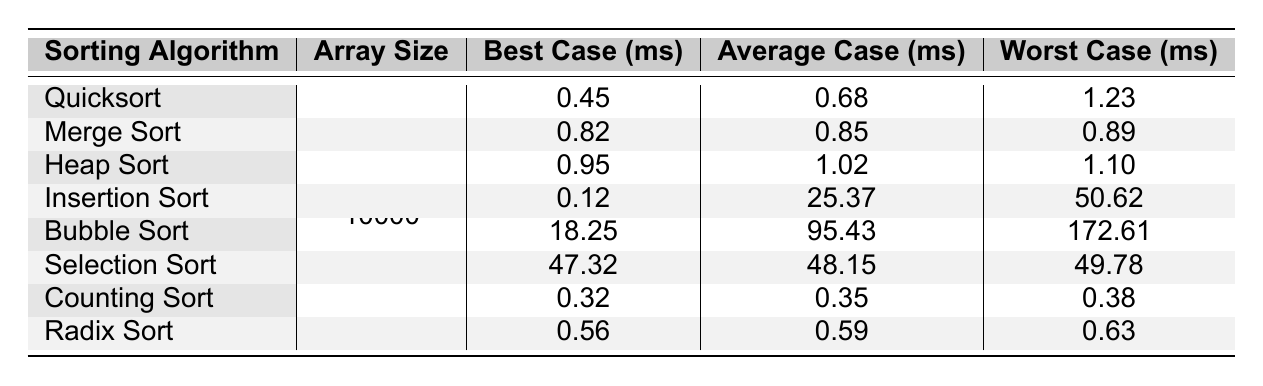What is the best case execution time for Quicksort? From the table, under the "Best Case (ms)" column for "Quicksort," the value is 0.45.
Answer: 0.45 ms Which sorting algorithm has the worst average case execution time? By looking at the "Average Case (ms)" column, "Insertion Sort" has the maximum value of 25.37 compared to others.
Answer: Insertion Sort What is the difference in the worst-case execution times between Bubble Sort and Counting Sort? The worst-case execution time for Bubble Sort is 172.61 ms and for Counting Sort is 0.38 ms. The difference is 172.61 - 0.38 = 172.23 ms.
Answer: 172.23 ms Which sorting algorithm has the minimum best case execution time? Reviewing the "Best Case (ms)" column reveals that "Counting Sort" has the minimum value of 0.32 ms.
Answer: Counting Sort Is the average case execution time for Merge Sort less than that for Radix Sort? The average case time for Merge Sort is 0.85 ms and for Radix Sort is 0.59 ms. Since 0.85 is greater than 0.59, the statement is False.
Answer: No What is the total of the best case execution times for Quicksort, Heap Sort, and Radix Sort? The best case times for these algorithms are 0.45 ms (Quicksort), 0.95 ms (Heap Sort), and 0.56 ms (Radix Sort). Summing these gives: 0.45 + 0.95 + 0.56 = 1.96 ms.
Answer: 1.96 ms Which algorithm had the highest worst-case execution time, and what was that time? In the "Worst Case (ms)" column, "Bubble Sort" has the highest value at 172.61 ms.
Answer: Bubble Sort, 172.61 ms Does any sorting algorithm have an average case execution time below 1 ms? Checking the "Average Case (ms)" column, all values are above 1 ms except for Counting Sort (0.35 ms). Thus, Yes, there is one.
Answer: Yes What is the median best case execution time of all the sorting algorithms listed? The best case times are: 0.12, 0.32, 0.45, 0.56, 0.82, 0.95, 18.25, 47.32. When sorted, the median is the average of the 4th and 5th values: (0.56 + 0.82) / 2 = 0.69.
Answer: 0.69 ms How does the worst case execution time of Insertion Sort compare to that of Selection Sort? The worst case for Insertion Sort is 50.62 ms, while for Selection Sort it is 49.78 ms. Insertion Sort's time is greater, so it is longer than Selection Sort.
Answer: Insertion Sort is longer 